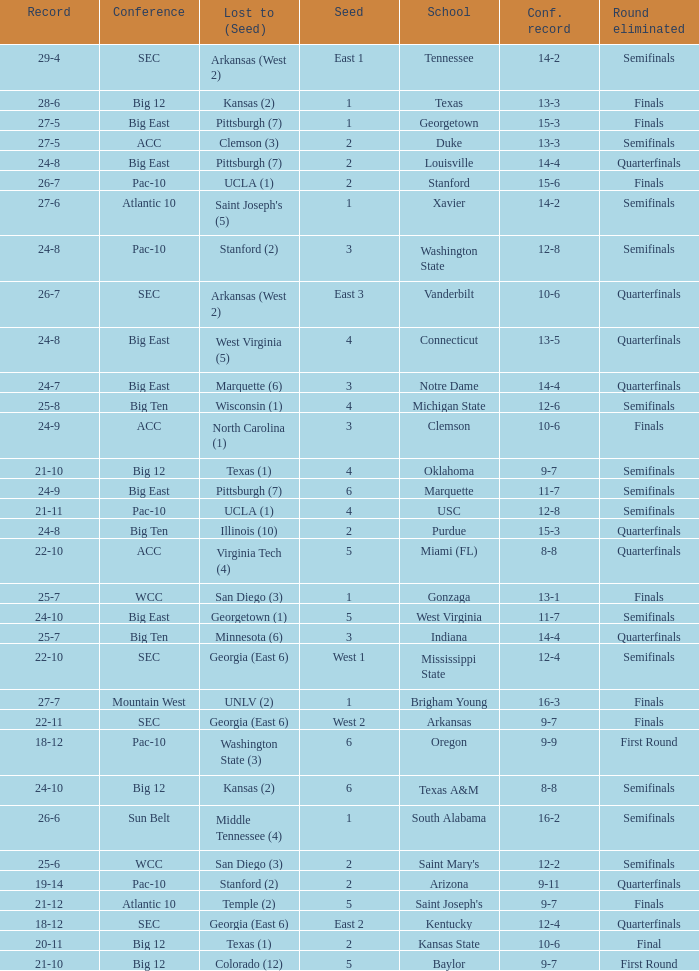Name the round eliminated where conference record is 12-6 Semifinals. 